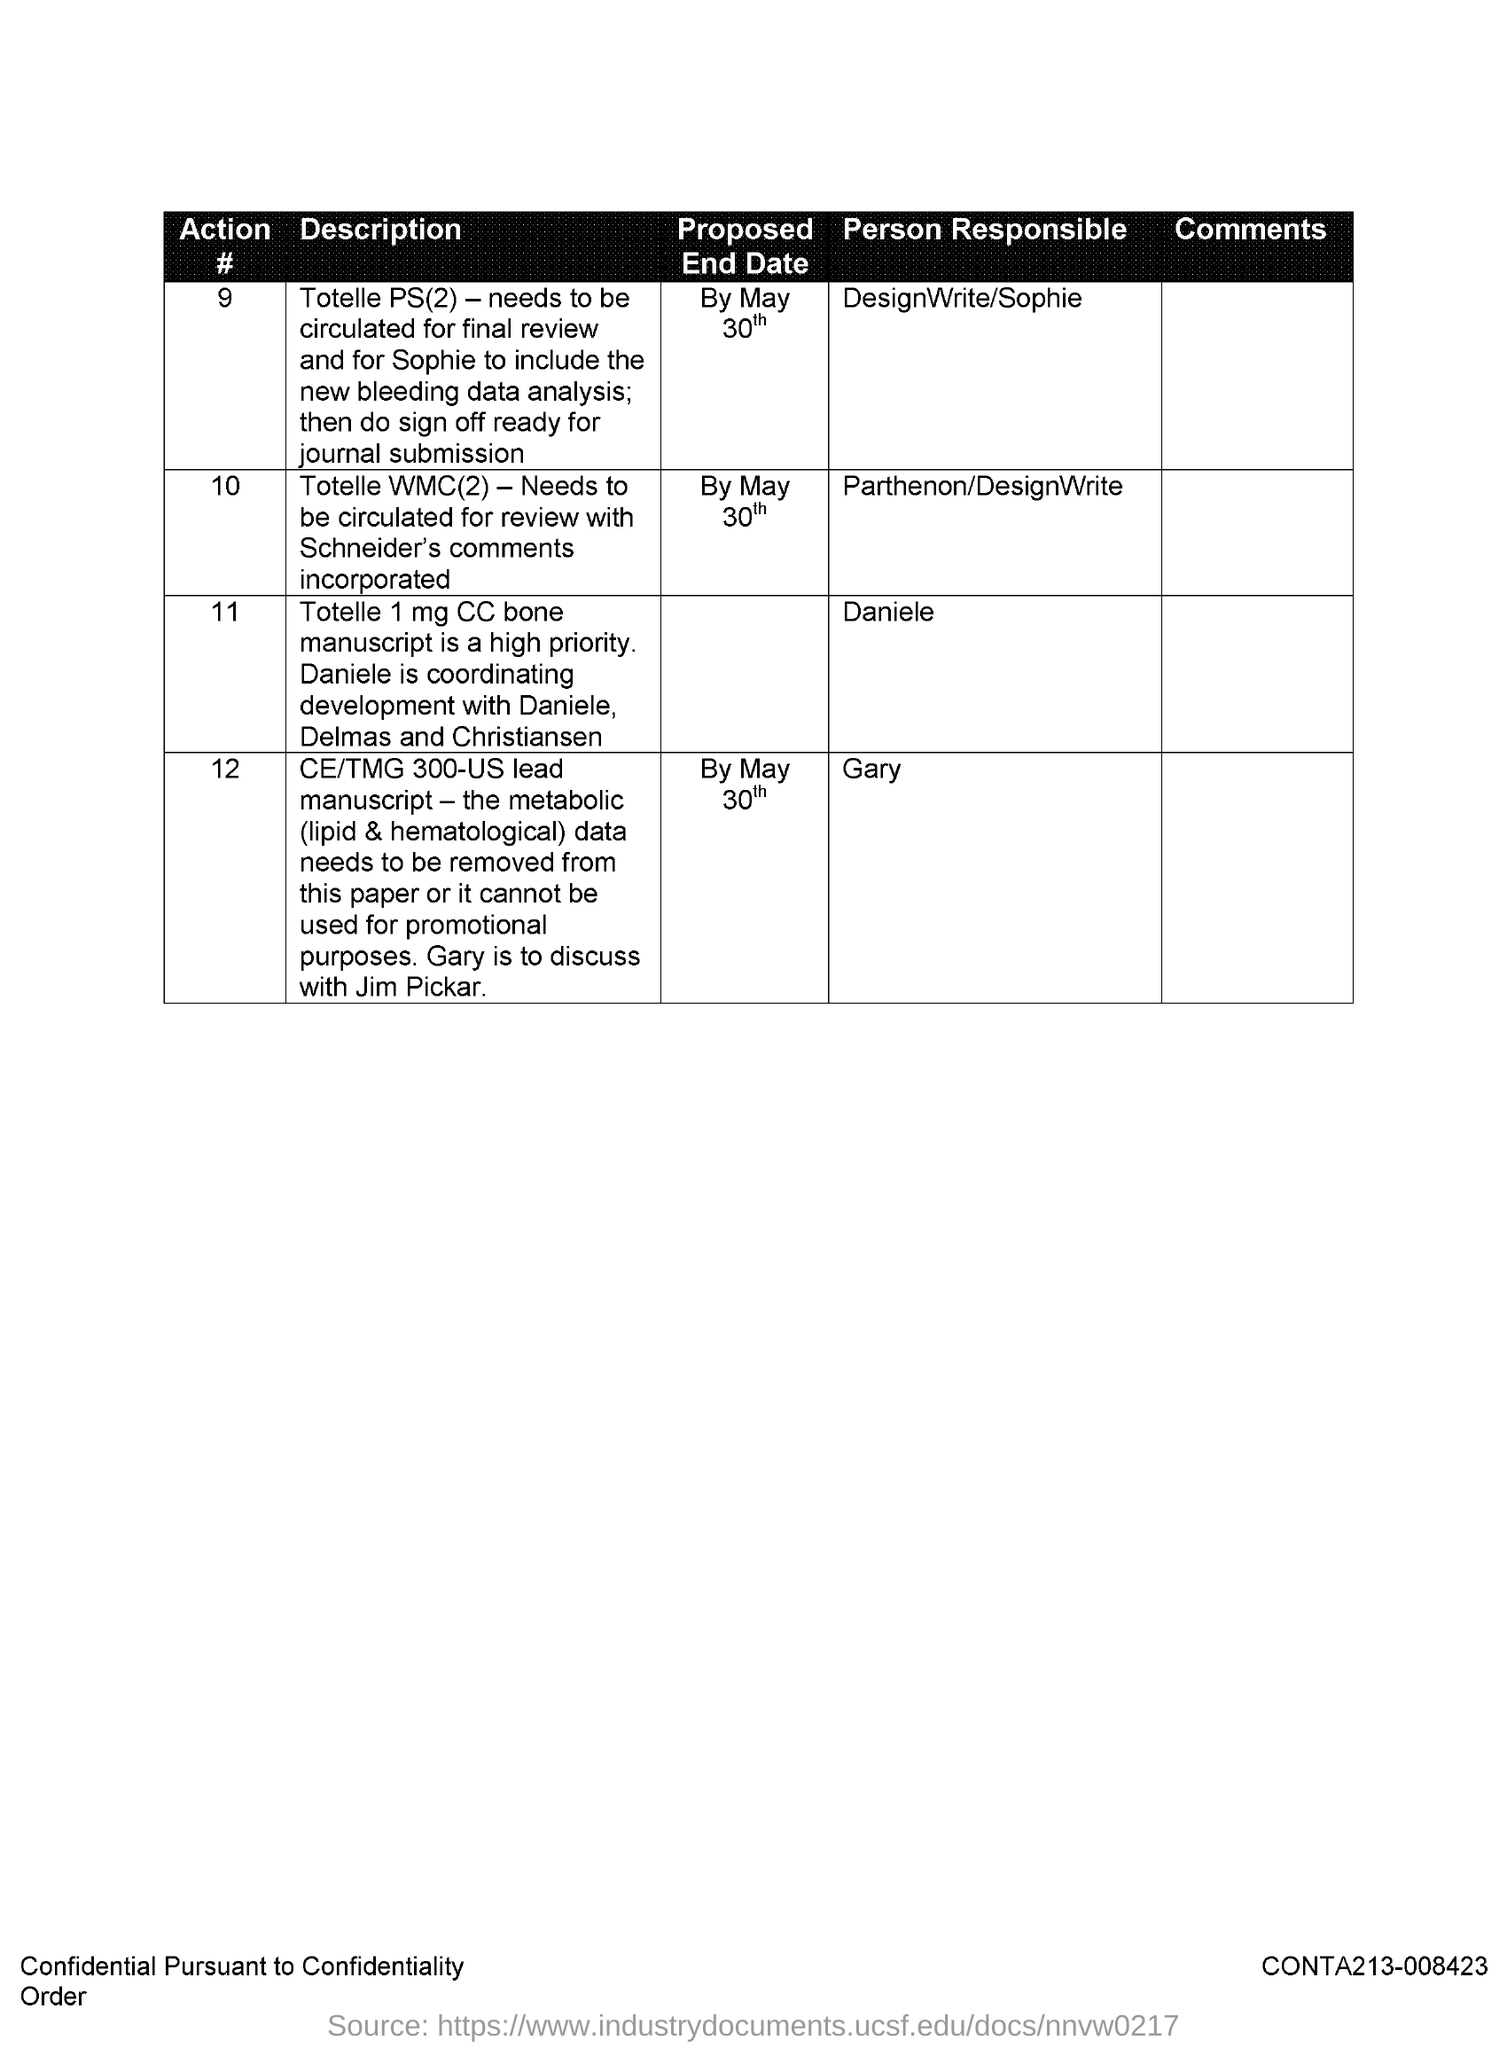Specify some key components in this picture. The responsible party for action number 10 is Parthenon/DesignWrite. Action number 11 is the responsibility of Daniele. The proposed end date for Action #10 is May 30th. Gary is responsible for action number 12. The proposed end date for Action #9 is May 30th. 